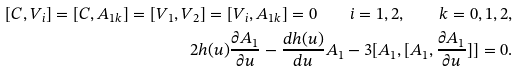Convert formula to latex. <formula><loc_0><loc_0><loc_500><loc_500>[ C , V _ { i } ] = [ C , A _ { 1 k } ] = [ V _ { 1 } , V _ { 2 } ] = [ V _ { i } , A _ { 1 k } ] = 0 \quad i = 1 , 2 , \quad k = 0 , 1 , 2 , \\ 2 h ( u ) \frac { \partial A _ { 1 } } { \partial u } - \frac { d h ( u ) } { d u } A _ { 1 } - 3 [ A _ { 1 } , [ A _ { 1 } , \frac { \partial A _ { 1 } } { \partial u } ] ] = 0 .</formula> 